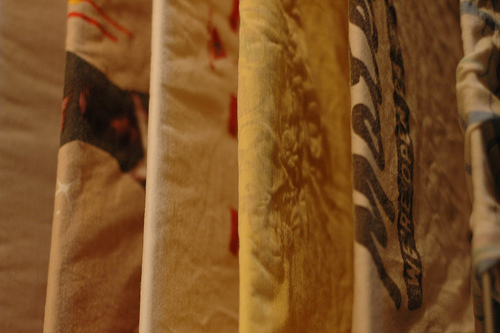<image>
Is the cloth in front of the rod? No. The cloth is not in front of the rod. The spatial positioning shows a different relationship between these objects. 